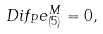<formula> <loc_0><loc_0><loc_500><loc_500>\ D i f _ { P } e ^ { M } _ { ( 5 ) } = 0 ,</formula> 